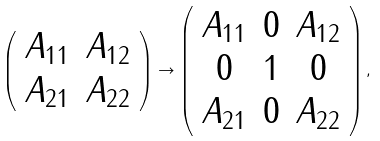<formula> <loc_0><loc_0><loc_500><loc_500>\left ( \begin{array} { c c } A _ { 1 1 } & A _ { 1 2 } \\ A _ { 2 1 } & A _ { 2 2 } \end{array} \right ) \to \left ( \begin{array} { c c c } A _ { 1 1 } & 0 & A _ { 1 2 } \\ 0 & 1 & 0 \\ A _ { 2 1 } & 0 & A _ { 2 2 } \end{array} \right ) ,</formula> 